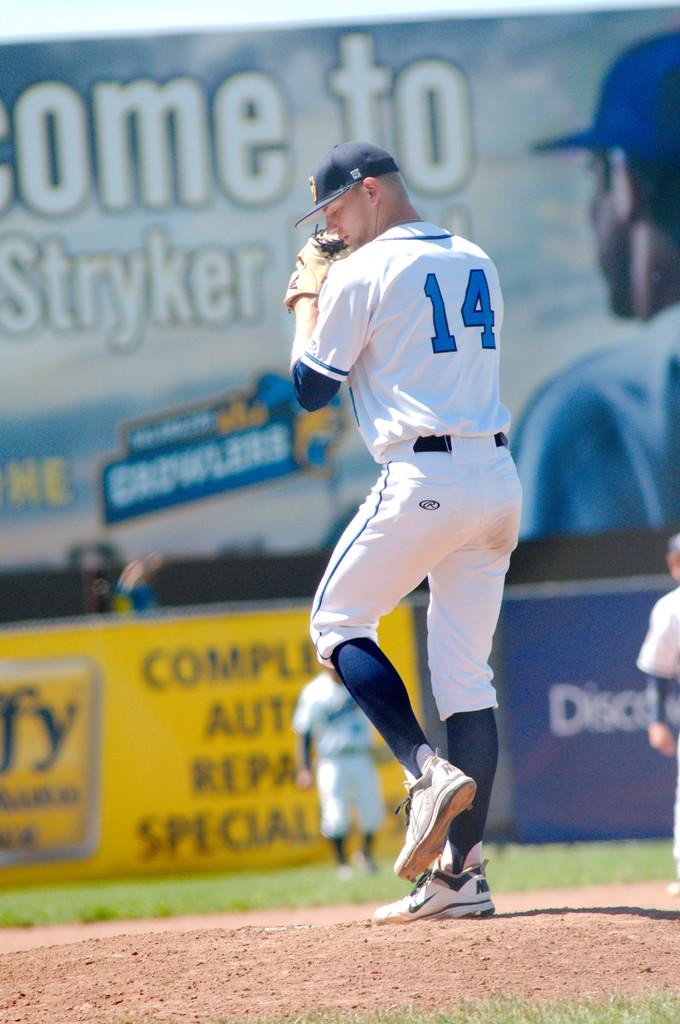Which player is that?
Give a very brief answer. 14. 